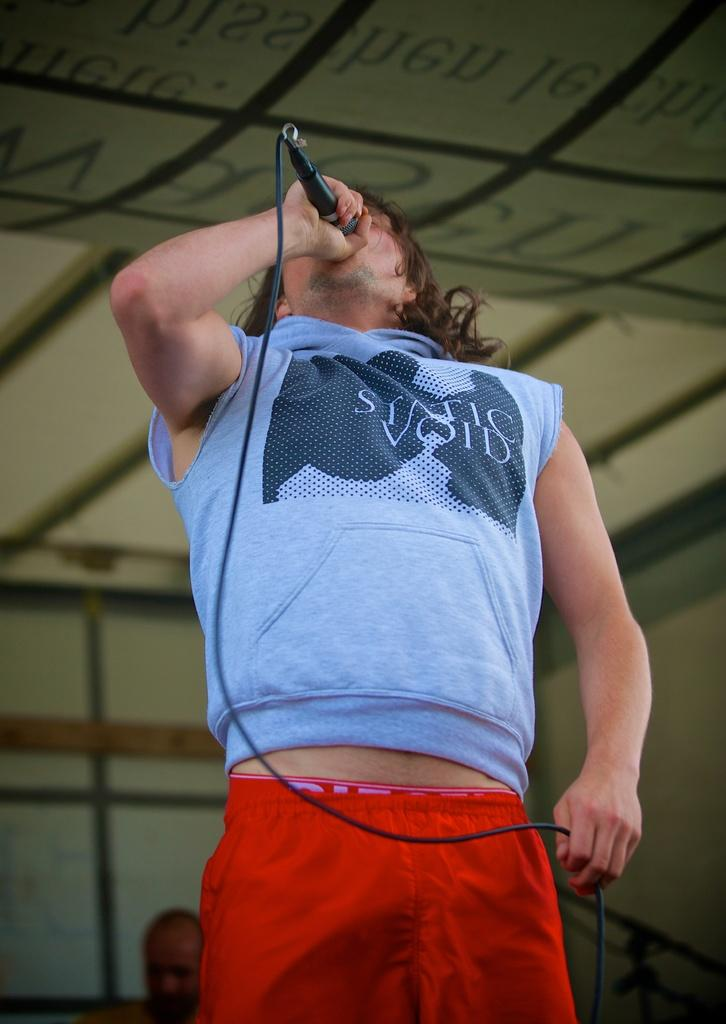Provide a one-sentence caption for the provided image. A man signing on stage with the phrase STATIC VOID written on his shirt. 